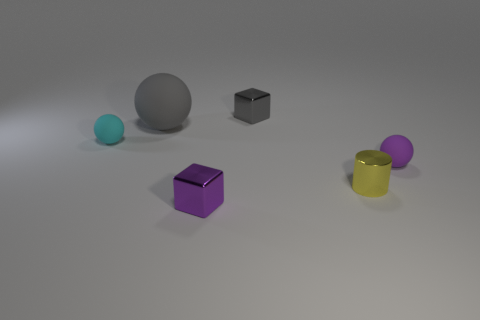Is there any other thing that is the same size as the gray ball?
Your answer should be compact. No. Is the color of the block behind the small purple matte object the same as the large rubber sphere behind the cylinder?
Your response must be concise. Yes. Do the object behind the gray matte thing and the cyan thing have the same size?
Keep it short and to the point. Yes. What number of things are there?
Your answer should be very brief. 6. How many objects are behind the purple matte sphere and right of the big gray sphere?
Your answer should be compact. 1. Are there any tiny purple things made of the same material as the small yellow cylinder?
Your answer should be compact. Yes. What is the material of the tiny ball that is in front of the tiny rubber thing that is behind the purple matte thing?
Provide a succinct answer. Rubber. Are there the same number of yellow metallic objects that are right of the large gray rubber ball and yellow shiny things that are in front of the small purple metallic cube?
Your answer should be compact. No. Do the purple shiny object and the small gray thing have the same shape?
Keep it short and to the point. Yes. There is a object that is in front of the small gray shiny block and behind the cyan thing; what material is it made of?
Provide a succinct answer. Rubber. 